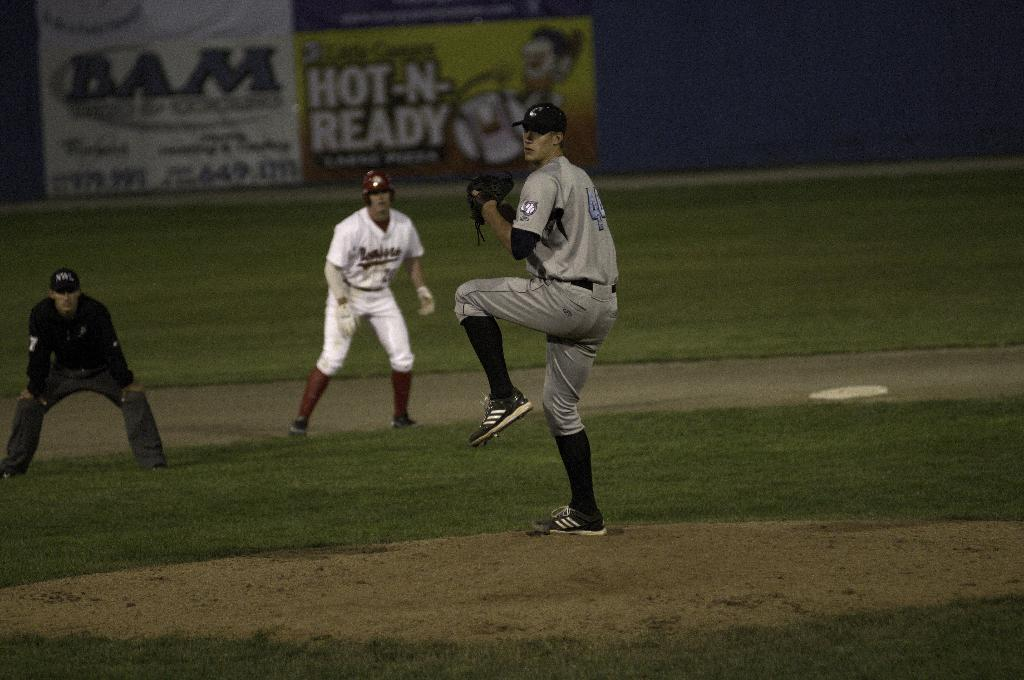<image>
Provide a brief description of the given image. A baseball player has the number 44 on his jersey on the back. 